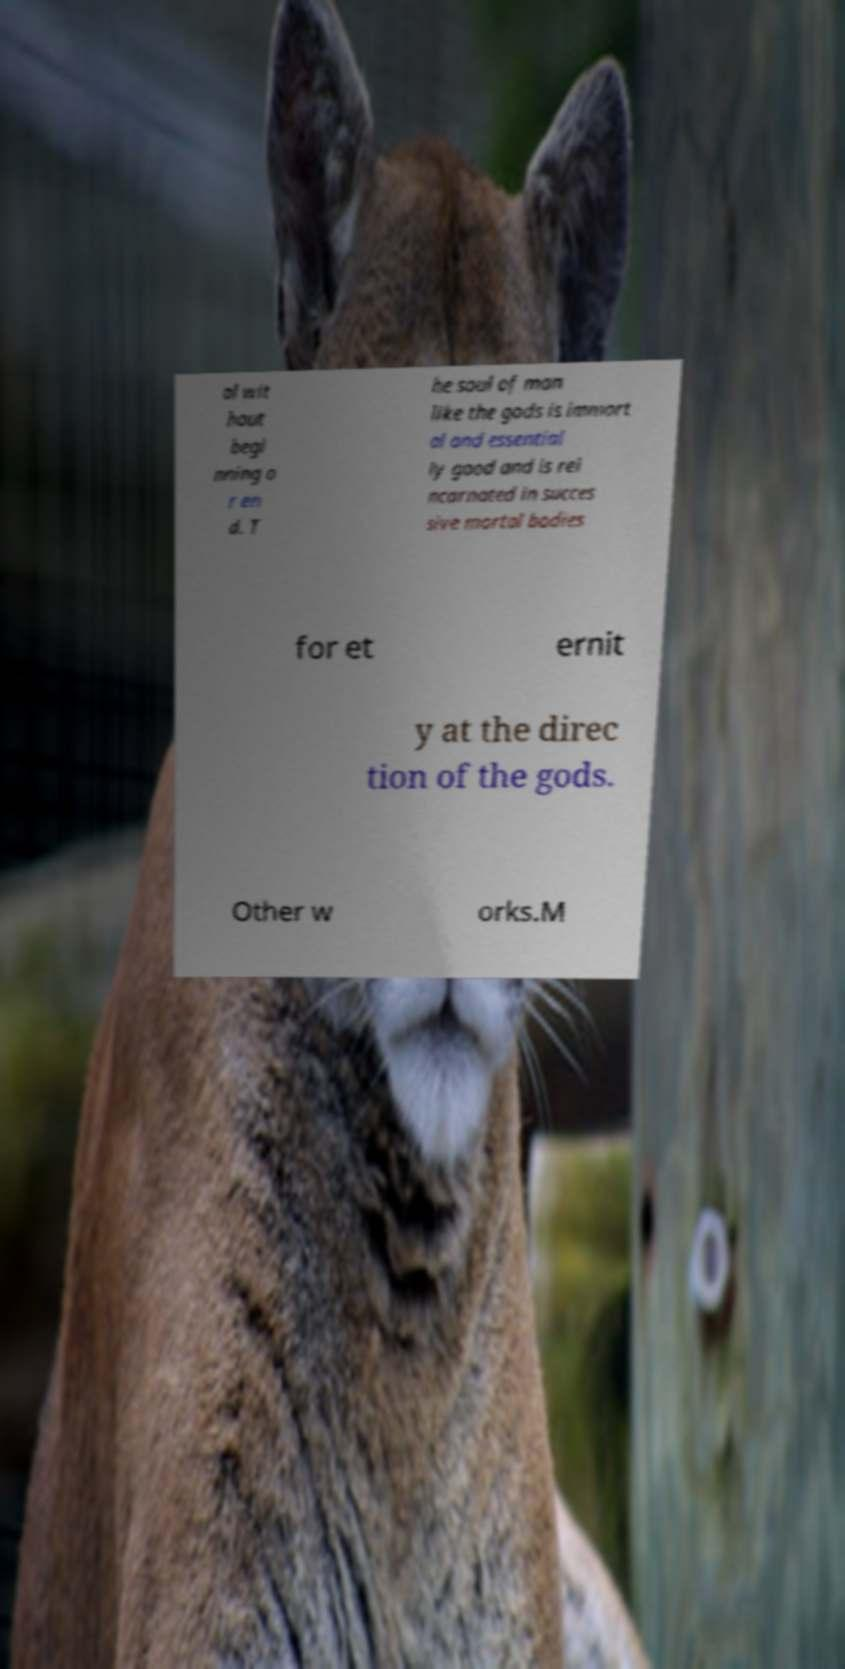What messages or text are displayed in this image? I need them in a readable, typed format. al wit hout begi nning o r en d. T he soul of man like the gods is immort al and essential ly good and is rei ncarnated in succes sive mortal bodies for et ernit y at the direc tion of the gods. Other w orks.M 